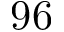Convert formula to latex. <formula><loc_0><loc_0><loc_500><loc_500>9 6</formula> 